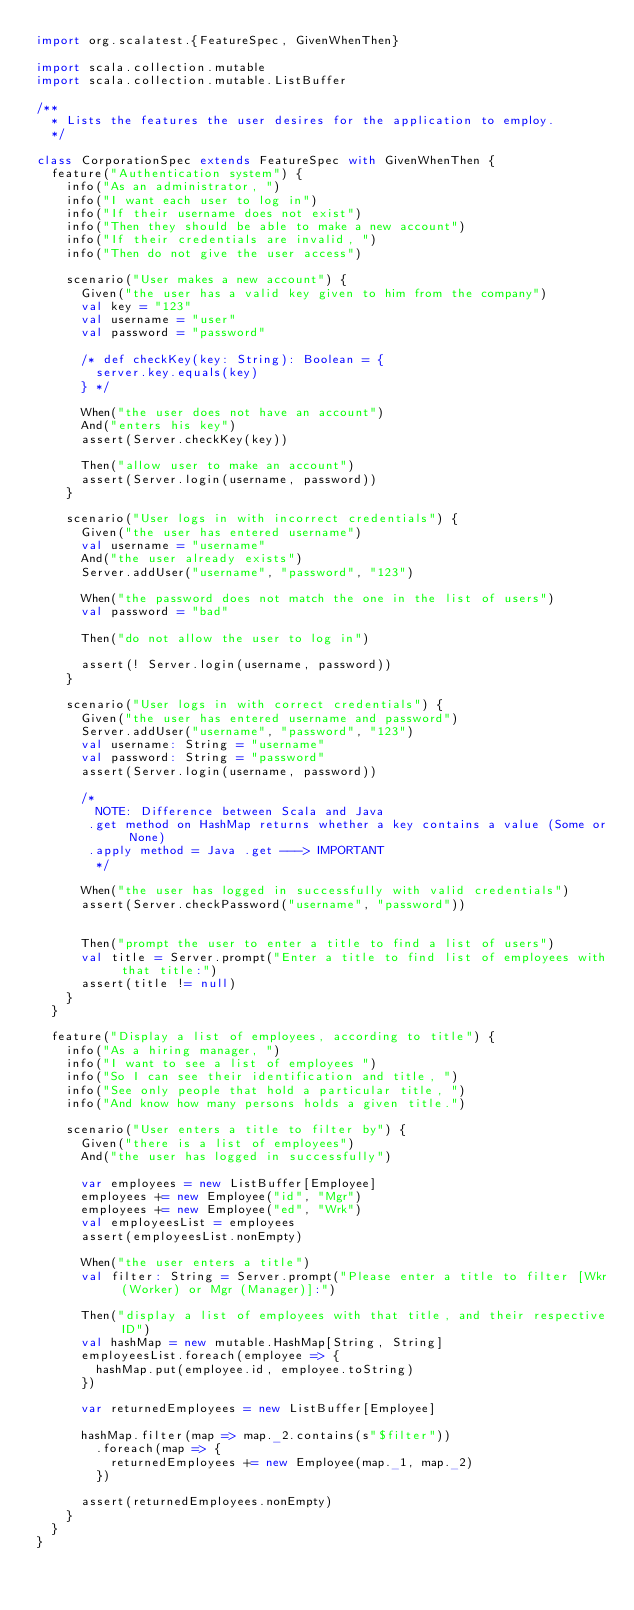Convert code to text. <code><loc_0><loc_0><loc_500><loc_500><_Scala_>import org.scalatest.{FeatureSpec, GivenWhenThen}

import scala.collection.mutable
import scala.collection.mutable.ListBuffer

/**
  * Lists the features the user desires for the application to employ.
  */

class CorporationSpec extends FeatureSpec with GivenWhenThen {
  feature("Authentication system") {
    info("As an administrator, ")
    info("I want each user to log in")
    info("If their username does not exist")
    info("Then they should be able to make a new account")
    info("If their credentials are invalid, ")
    info("Then do not give the user access")

    scenario("User makes a new account") {
      Given("the user has a valid key given to him from the company")
      val key = "123"
      val username = "user"
      val password = "password"

      /* def checkKey(key: String): Boolean = {
        server.key.equals(key)
      } */

      When("the user does not have an account")
      And("enters his key")
      assert(Server.checkKey(key))

      Then("allow user to make an account")
      assert(Server.login(username, password))
    }

    scenario("User logs in with incorrect credentials") {
      Given("the user has entered username")
      val username = "username"
      And("the user already exists")
      Server.addUser("username", "password", "123")

      When("the password does not match the one in the list of users")
      val password = "bad"

      Then("do not allow the user to log in")

      assert(! Server.login(username, password))
    }

    scenario("User logs in with correct credentials") {
      Given("the user has entered username and password")
      Server.addUser("username", "password", "123")
      val username: String = "username"
      val password: String = "password"
      assert(Server.login(username, password))

      /*
        NOTE: Difference between Scala and Java
       .get method on HashMap returns whether a key contains a value (Some or None)
       .apply method = Java .get ---> IMPORTANT
        */

      When("the user has logged in successfully with valid credentials")
      assert(Server.checkPassword("username", "password"))


      Then("prompt the user to enter a title to find a list of users")
      val title = Server.prompt("Enter a title to find list of employees with that title:")
      assert(title != null)
    }
  }

  feature("Display a list of employees, according to title") {
    info("As a hiring manager, ")
    info("I want to see a list of employees ")
    info("So I can see their identification and title, ")
    info("See only people that hold a particular title, ")
    info("And know how many persons holds a given title.")

    scenario("User enters a title to filter by") {
      Given("there is a list of employees")
      And("the user has logged in successfully")

      var employees = new ListBuffer[Employee]
      employees += new Employee("id", "Mgr")
      employees += new Employee("ed", "Wrk")
      val employeesList = employees
      assert(employeesList.nonEmpty)

      When("the user enters a title")
      val filter: String = Server.prompt("Please enter a title to filter [Wkr (Worker) or Mgr (Manager)]:")

      Then("display a list of employees with that title, and their respective ID")
      val hashMap = new mutable.HashMap[String, String]
      employeesList.foreach(employee => {
        hashMap.put(employee.id, employee.toString)
      })

      var returnedEmployees = new ListBuffer[Employee]

      hashMap.filter(map => map._2.contains(s"$filter"))
        .foreach(map => {
          returnedEmployees += new Employee(map._1, map._2)
        })

      assert(returnedEmployees.nonEmpty)
    }
  }
}
</code> 